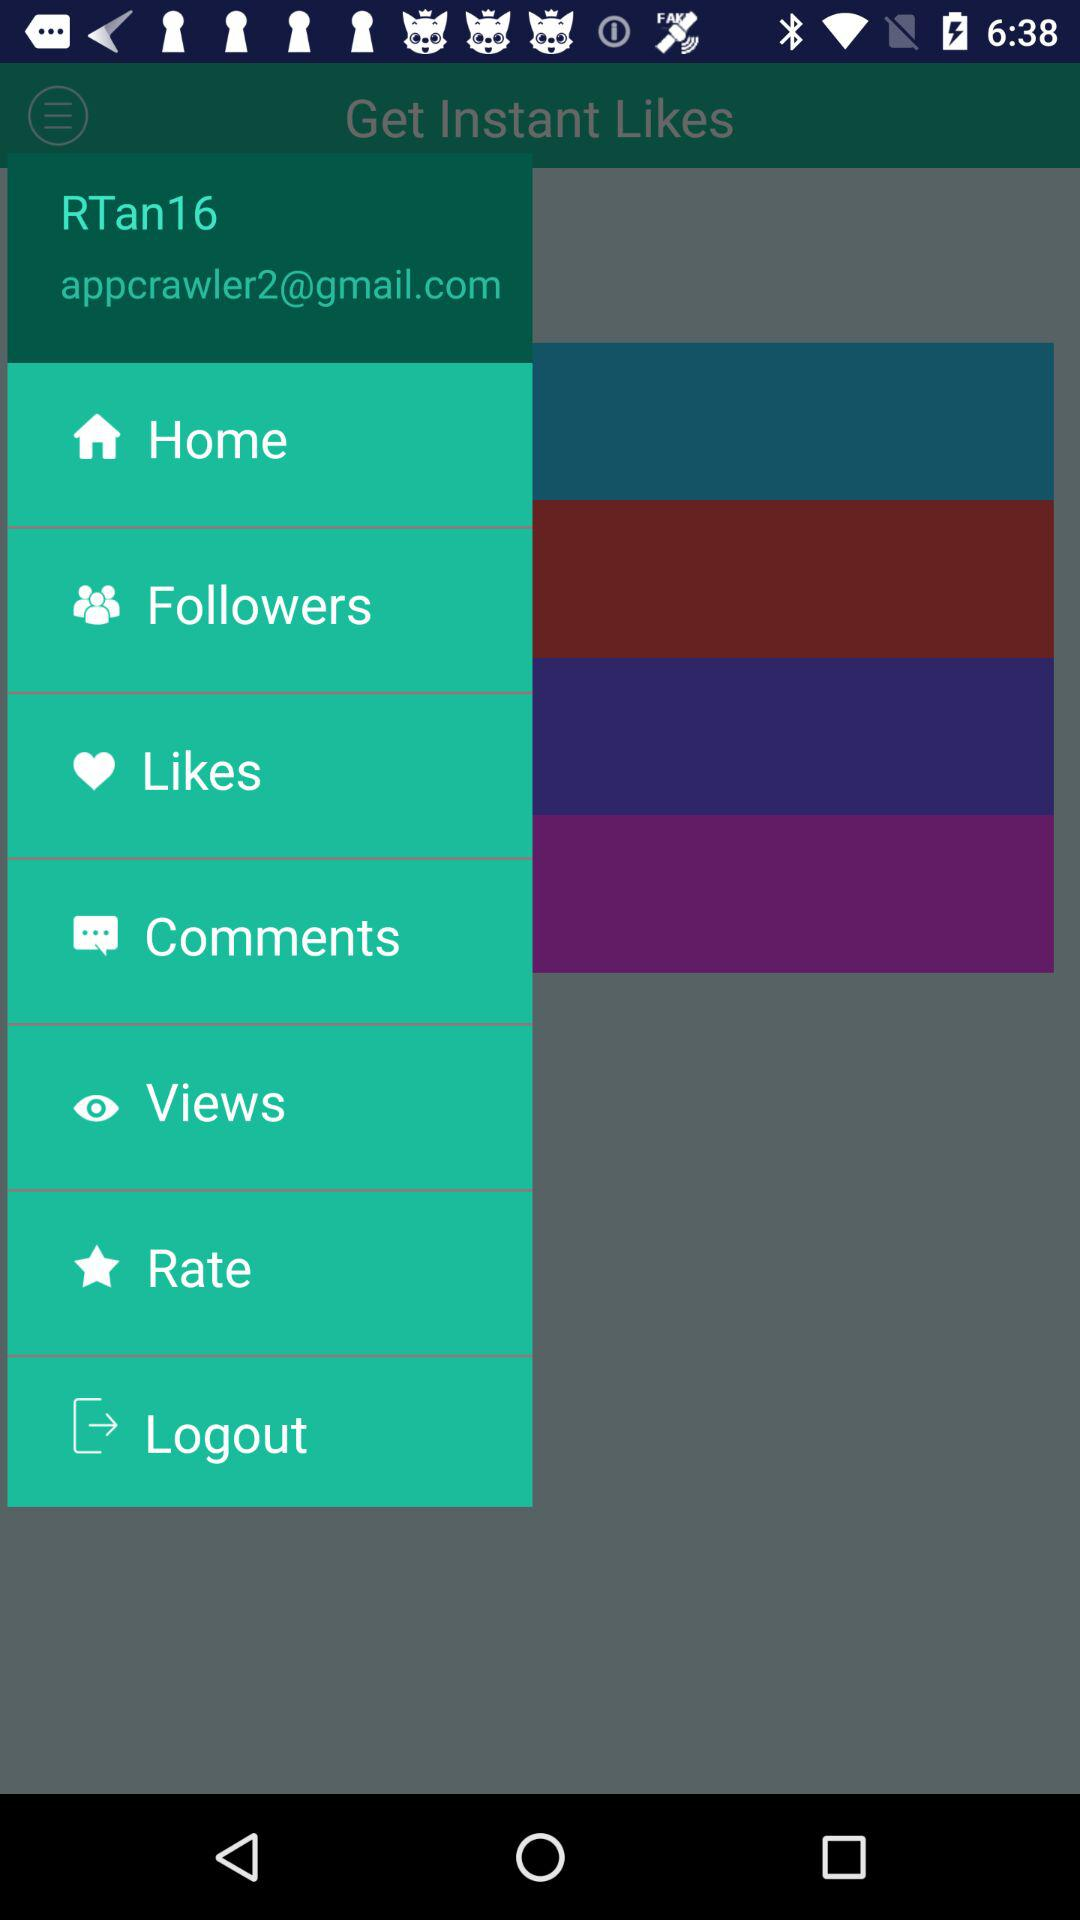What is the email address of the user? The email address is appcrawler2@gmail.com. 